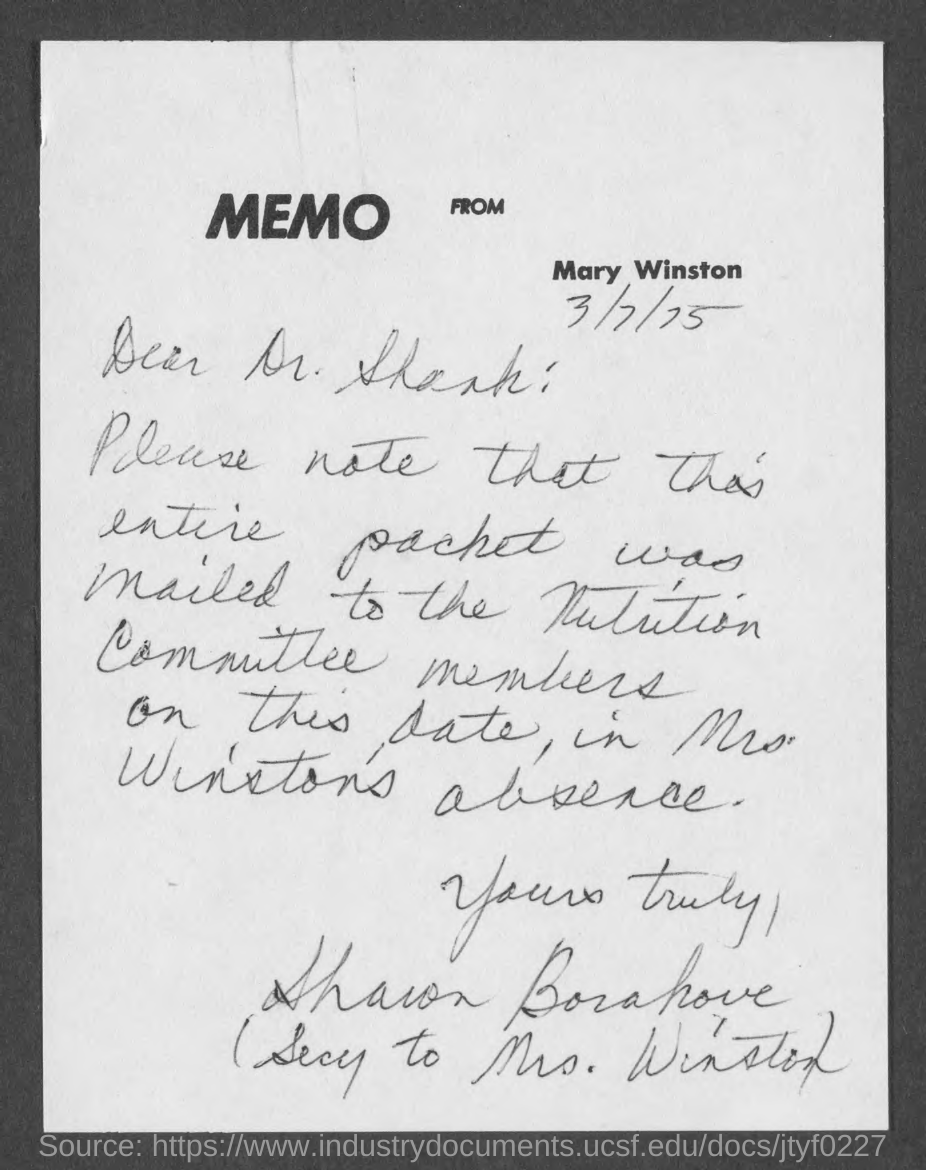Where is the memo from?
Provide a short and direct response. Mary Winston. 